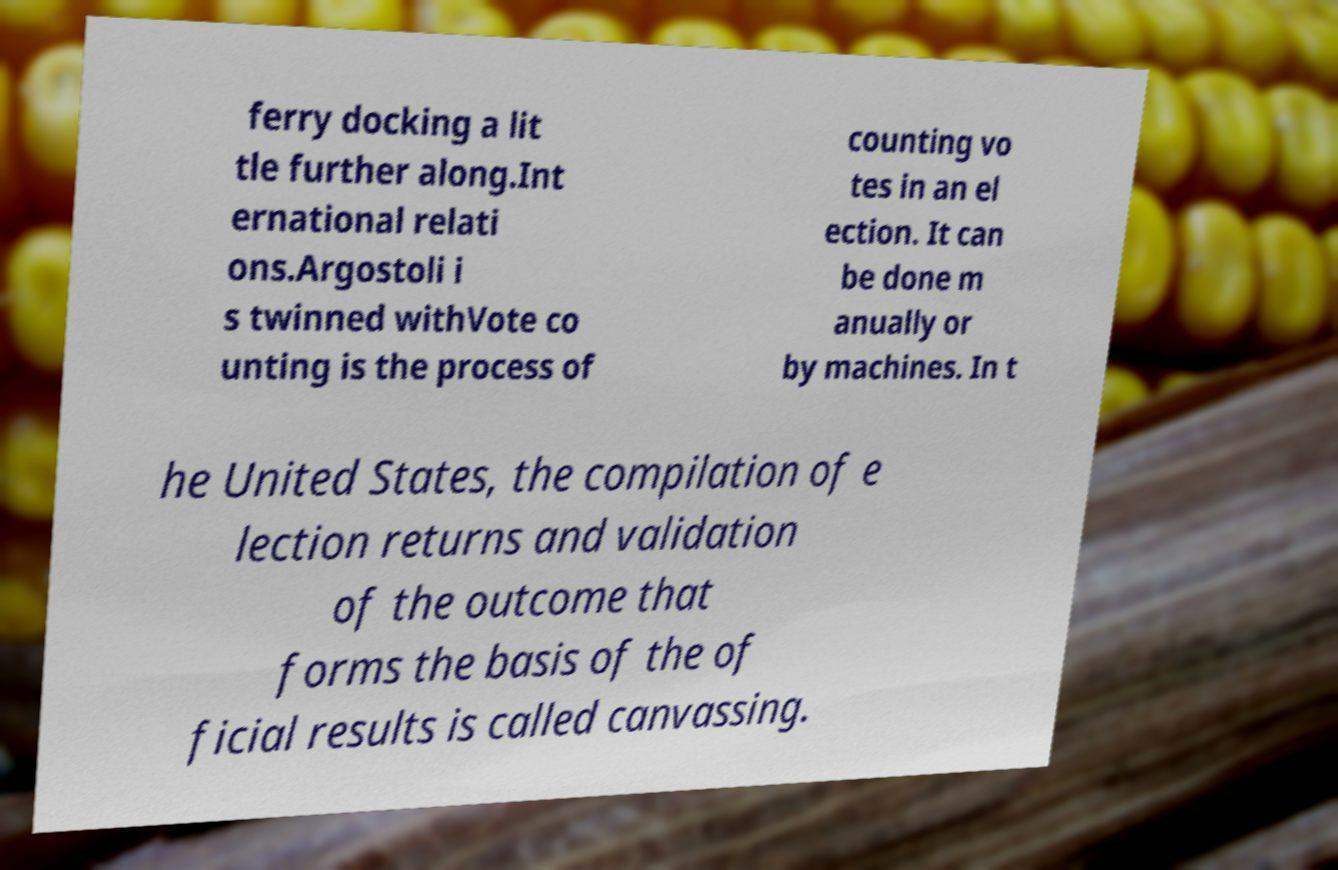For documentation purposes, I need the text within this image transcribed. Could you provide that? ferry docking a lit tle further along.Int ernational relati ons.Argostoli i s twinned withVote co unting is the process of counting vo tes in an el ection. It can be done m anually or by machines. In t he United States, the compilation of e lection returns and validation of the outcome that forms the basis of the of ficial results is called canvassing. 